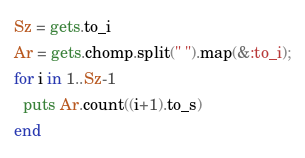Convert code to text. <code><loc_0><loc_0><loc_500><loc_500><_Ruby_>Sz = gets.to_i
Ar = gets.chomp.split(" ").map(&:to_i);
for i in 1..Sz-1
  puts Ar.count((i+1).to_s)
end</code> 